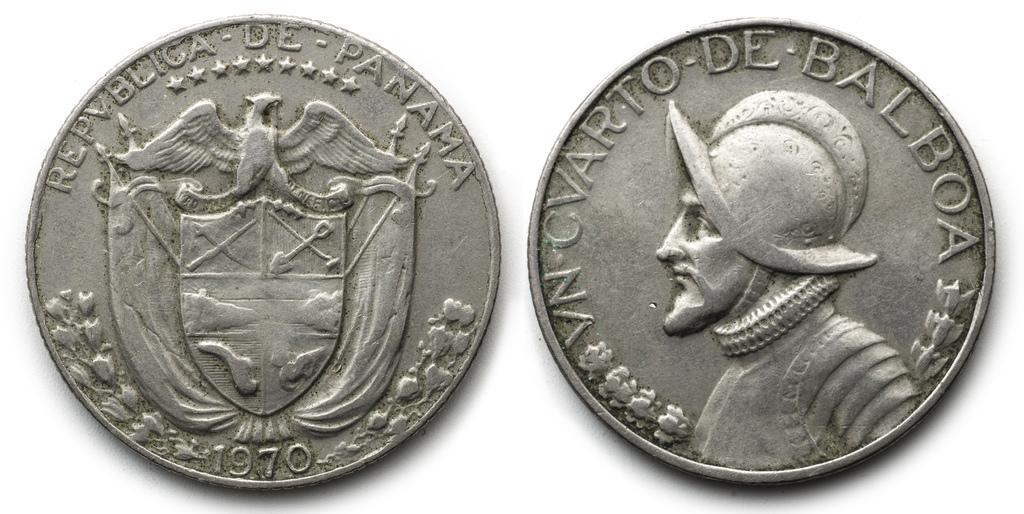<image>
Present a compact description of the photo's key features. A front and back view of a 1970 coin from Panama. 